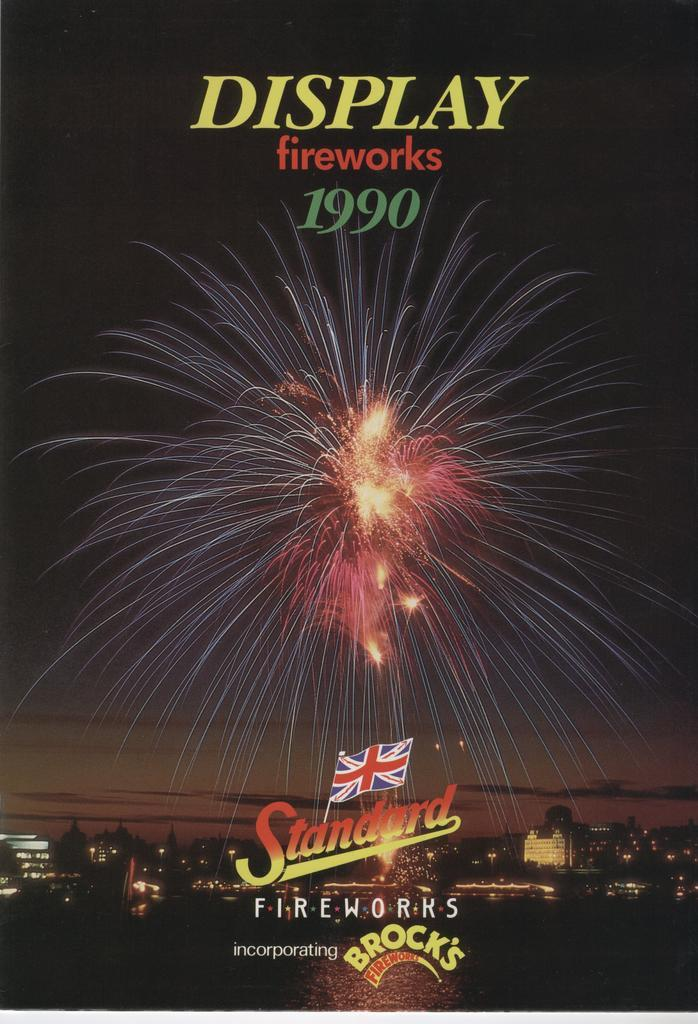<image>
Create a compact narrative representing the image presented. A poster for a fireworks display in 1990 that uses Standard and Brock's fireworks. 